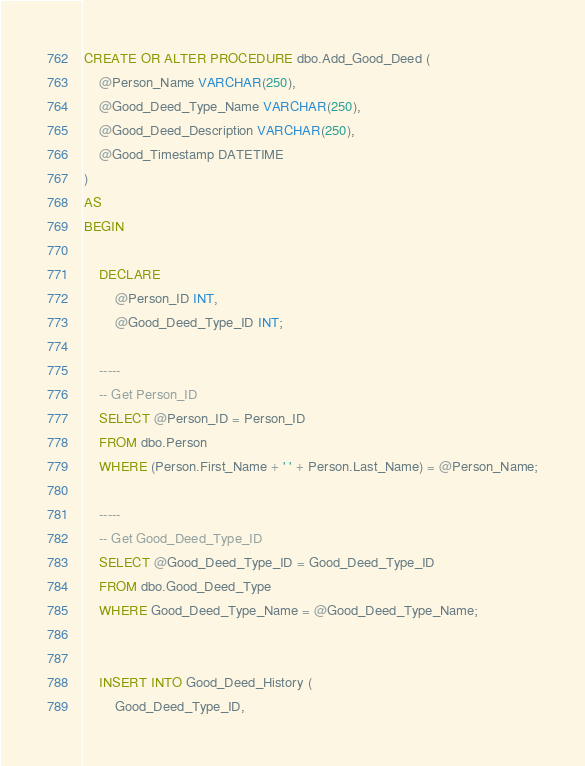<code> <loc_0><loc_0><loc_500><loc_500><_SQL_>
CREATE OR ALTER PROCEDURE dbo.Add_Good_Deed (
	@Person_Name VARCHAR(250),
	@Good_Deed_Type_Name VARCHAR(250),
	@Good_Deed_Description VARCHAR(250),
	@Good_Timestamp DATETIME
)
AS
BEGIN

	DECLARE 
		@Person_ID INT,
		@Good_Deed_Type_ID INT;

	-----
	-- Get Person_ID
	SELECT @Person_ID = Person_ID
	FROM dbo.Person
	WHERE (Person.First_Name + ' ' + Person.Last_Name) = @Person_Name;

	-----
	-- Get Good_Deed_Type_ID
	SELECT @Good_Deed_Type_ID = Good_Deed_Type_ID
	FROM dbo.Good_Deed_Type
	WHERE Good_Deed_Type_Name = @Good_Deed_Type_Name;

	
	INSERT INTO Good_Deed_History (
		Good_Deed_Type_ID, </code> 